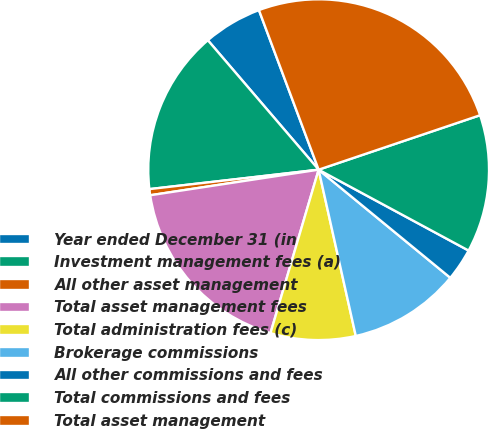Convert chart. <chart><loc_0><loc_0><loc_500><loc_500><pie_chart><fcel>Year ended December 31 (in<fcel>Investment management fees (a)<fcel>All other asset management<fcel>Total asset management fees<fcel>Total administration fees (c)<fcel>Brokerage commissions<fcel>All other commissions and fees<fcel>Total commissions and fees<fcel>Total asset management<nl><fcel>5.57%<fcel>15.55%<fcel>0.58%<fcel>18.04%<fcel>8.06%<fcel>10.56%<fcel>3.07%<fcel>13.05%<fcel>25.52%<nl></chart> 